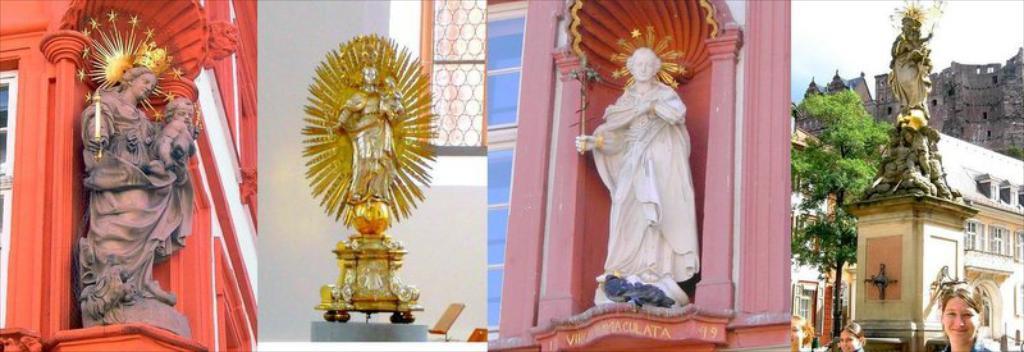Describe this image in one or two sentences. This is a collage image of different statues. 